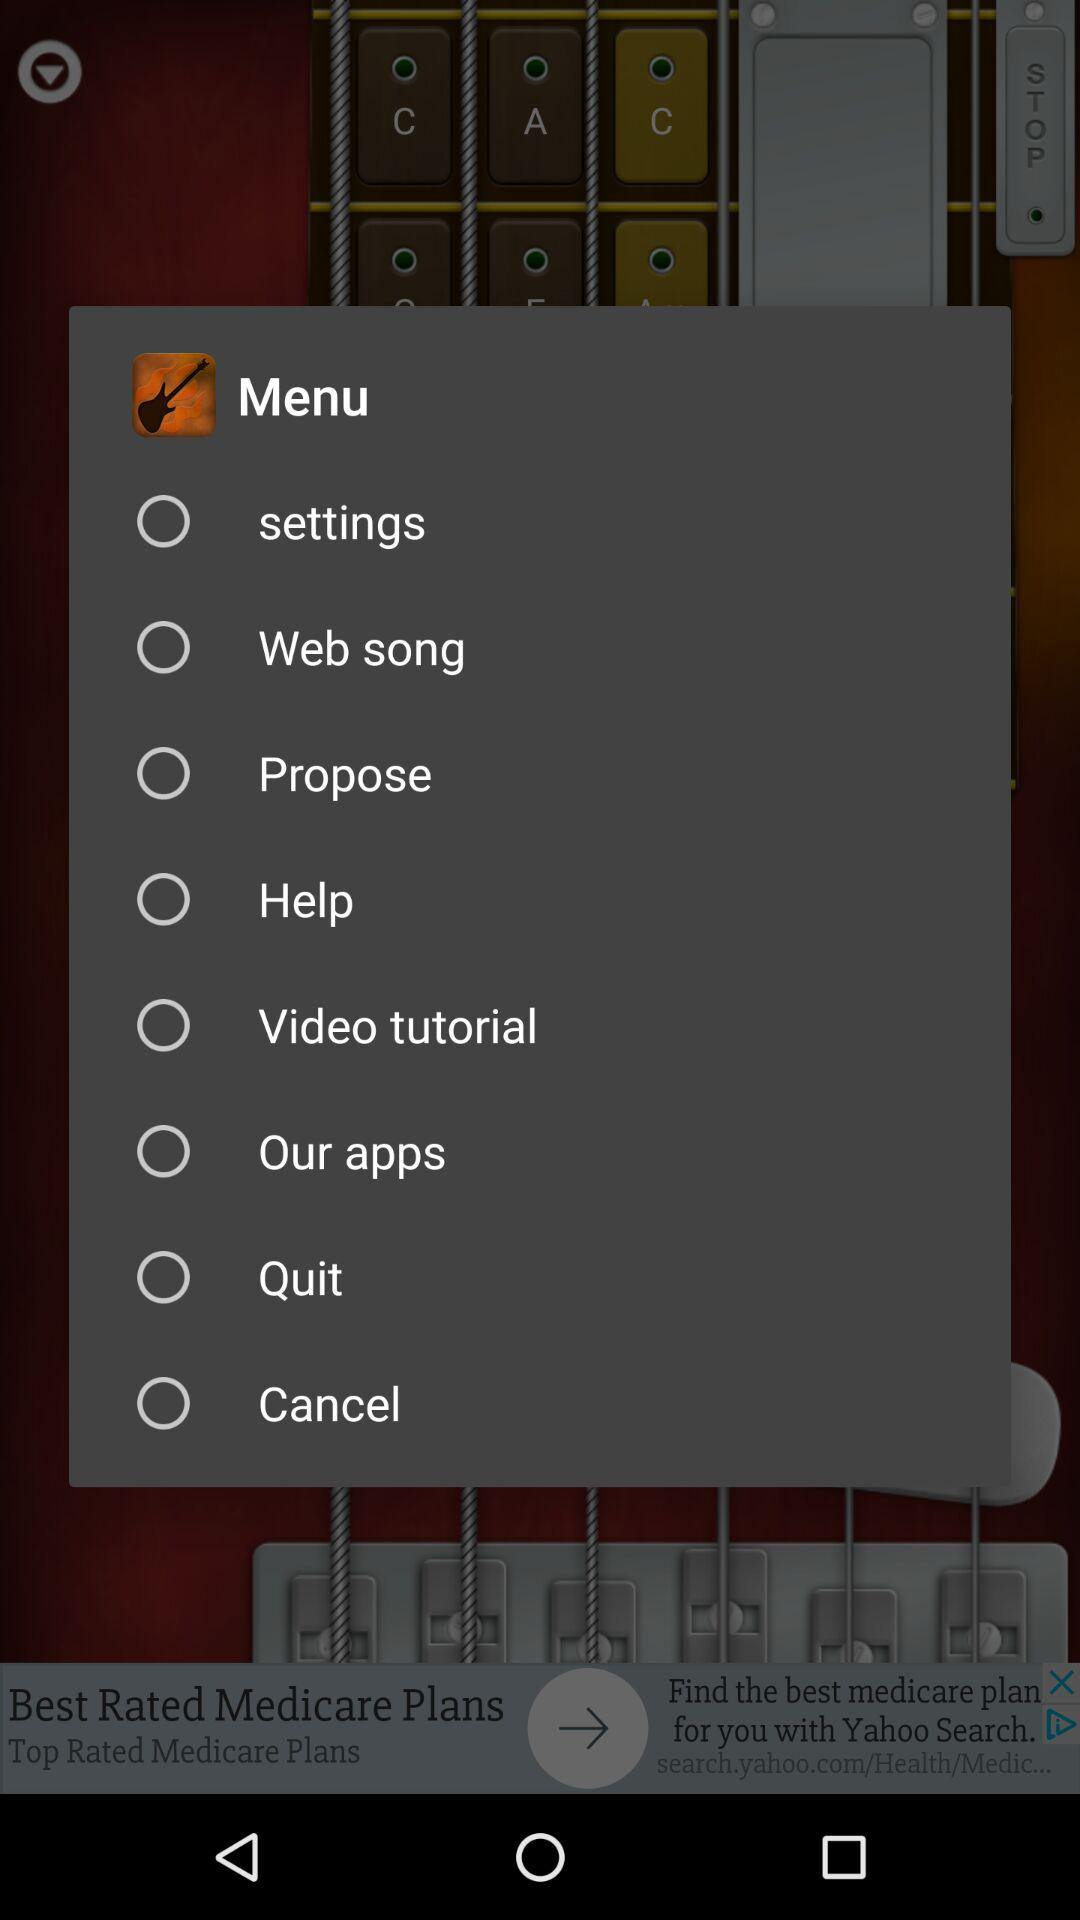How many items are in the menu?
Answer the question using a single word or phrase. 8 